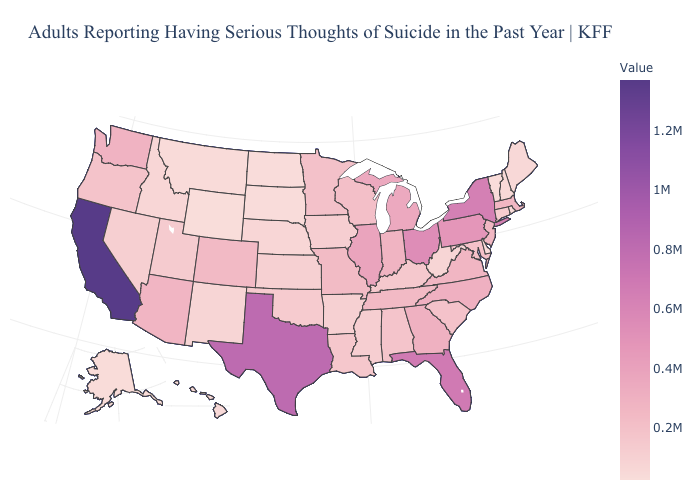Among the states that border South Dakota , does Wyoming have the highest value?
Concise answer only. No. Does Wyoming have the lowest value in the USA?
Keep it brief. Yes. Which states have the lowest value in the USA?
Write a very short answer. Wyoming. Which states have the highest value in the USA?
Write a very short answer. California. Which states have the lowest value in the South?
Keep it brief. Delaware. Does Virginia have the highest value in the South?
Be succinct. No. Does California have the highest value in the USA?
Answer briefly. Yes. 